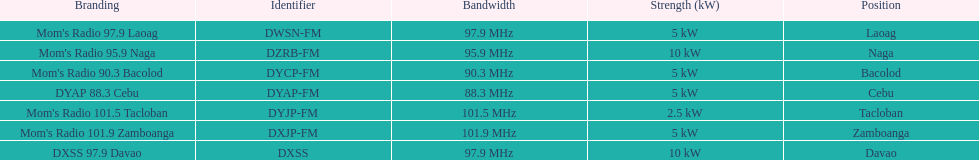What is the only radio station with a frequency below 90 mhz? DYAP 88.3 Cebu. 